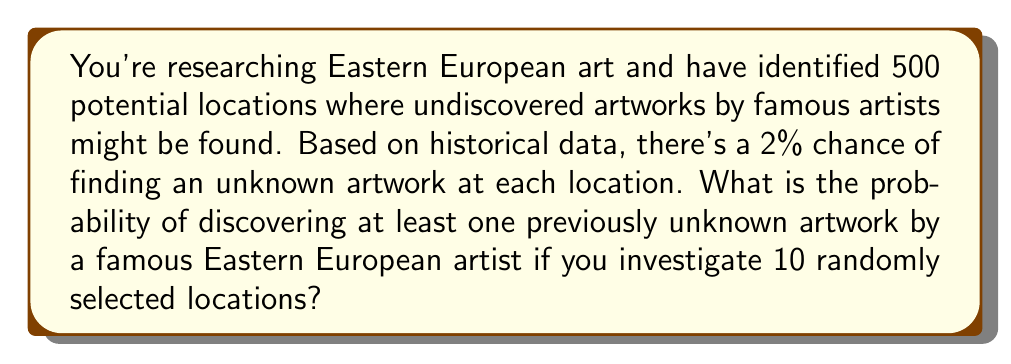Can you answer this question? Let's approach this step-by-step:

1) First, let's define our events:
   - Success: Finding an unknown artwork
   - Failure: Not finding an unknown artwork

2) The probability of success at each location is 2% or 0.02
   The probability of failure at each location is 1 - 0.02 = 0.98

3) We want to find the probability of at least one success in 10 trials. It's easier to calculate the probability of no successes and then subtract from 1.

4) The probability of no successes in 10 trials is:
   $$(0.98)^{10} = 0.8171$$

5) Therefore, the probability of at least one success is:
   $$1 - (0.98)^{10} = 1 - 0.8171 = 0.1829$$

6) We can also verify this using the binomial probability formula:
   $$P(X \geq 1) = 1 - P(X = 0)$$
   $$= 1 - \binom{10}{0}(0.02)^0(0.98)^{10}$$
   $$= 1 - (1)(1)(0.8171) = 0.1829$$

Thus, the probability of discovering at least one previously unknown artwork by a famous Eastern European artist if you investigate 10 randomly selected locations is approximately 0.1829 or 18.29%.
Answer: 0.1829 or 18.29% 